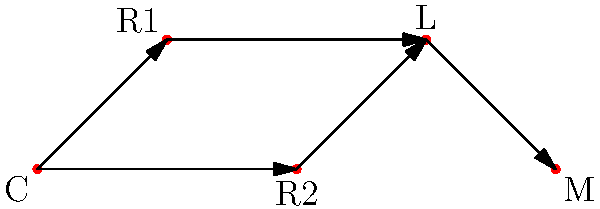In the graph representing a customer's interaction network with a company and legal entities, where C is the customer, R1 and R2 are company representatives, L is a lawyer, and M is a mediator, what is the minimum number of edges that need to be traversed for the customer to reach the mediator? To determine the minimum number of edges that need to be traversed for the customer (C) to reach the mediator (M), we need to analyze the shortest path between these two vertices:

1. Start at vertex C (customer).
2. From C, we have two options: R1 or R2. Both paths lead to L (lawyer), so we can choose either.
3. From R1 or R2, we must go to L (lawyer).
4. From L, we can reach M (mediator) directly.

The shortest path is:
C → R1 → L → M
or
C → R2 → L → M

Both paths require traversing 3 edges.

Therefore, the minimum number of edges that need to be traversed for the customer to reach the mediator is 3.
Answer: 3 